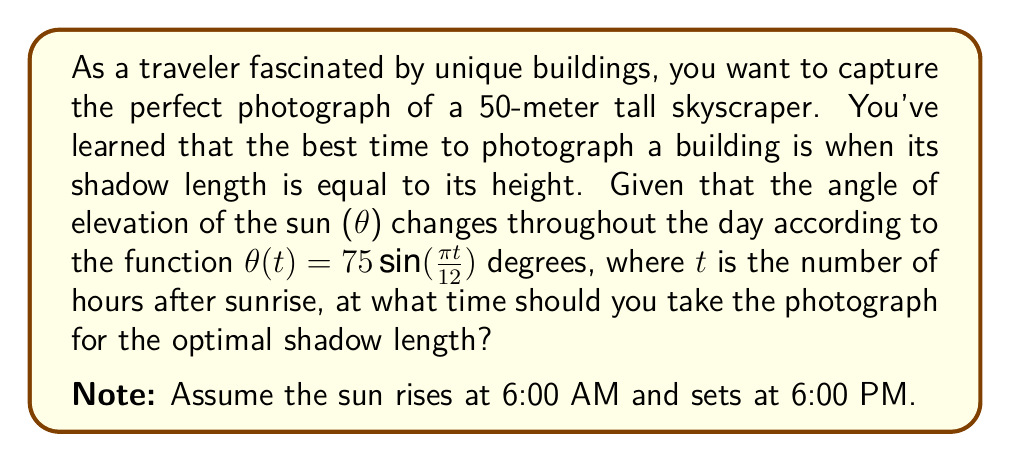Provide a solution to this math problem. To solve this problem, we'll follow these steps:

1) First, we need to understand the relationship between the building's height, shadow length, and the angle of elevation of the sun. This relationship is given by:

   $$ \tan(\theta) = \frac{\text{building height}}{\text{shadow length}} $$

2) We're told that the best time is when the shadow length equals the building height. In this case:

   $$ \tan(\theta) = \frac{50}{50} = 1 $$

3) This means we need to find when $\theta = 45°$, as $\tan(45°) = 1$.

4) We're given the function for θ in terms of t:

   $$ \theta(t) = 75\sin(\frac{\pi t}{12}) $$

5) We need to solve:

   $$ 45 = 75\sin(\frac{\pi t}{12}) $$

6) Dividing both sides by 75:

   $$ \frac{3}{5} = \sin(\frac{\pi t}{12}) $$

7) Taking the inverse sine (arcsin) of both sides:

   $$ t = \frac{12}{\pi} \arcsin(\frac{3}{5}) $$

8) Calculating this (you can use a calculator):

   $$ t \approx 4.43 \text{ hours after sunrise} $$

9) Since sunrise is at 6:00 AM, we add 4.43 hours to 6:00 AM:

   $$ 6:00 \text{ AM} + 4:43 \approx 10:26 \text{ AM} $$

Therefore, the best time to photograph the building is approximately 10:26 AM.
Answer: The optimal time to photograph the building is approximately 10:26 AM. 